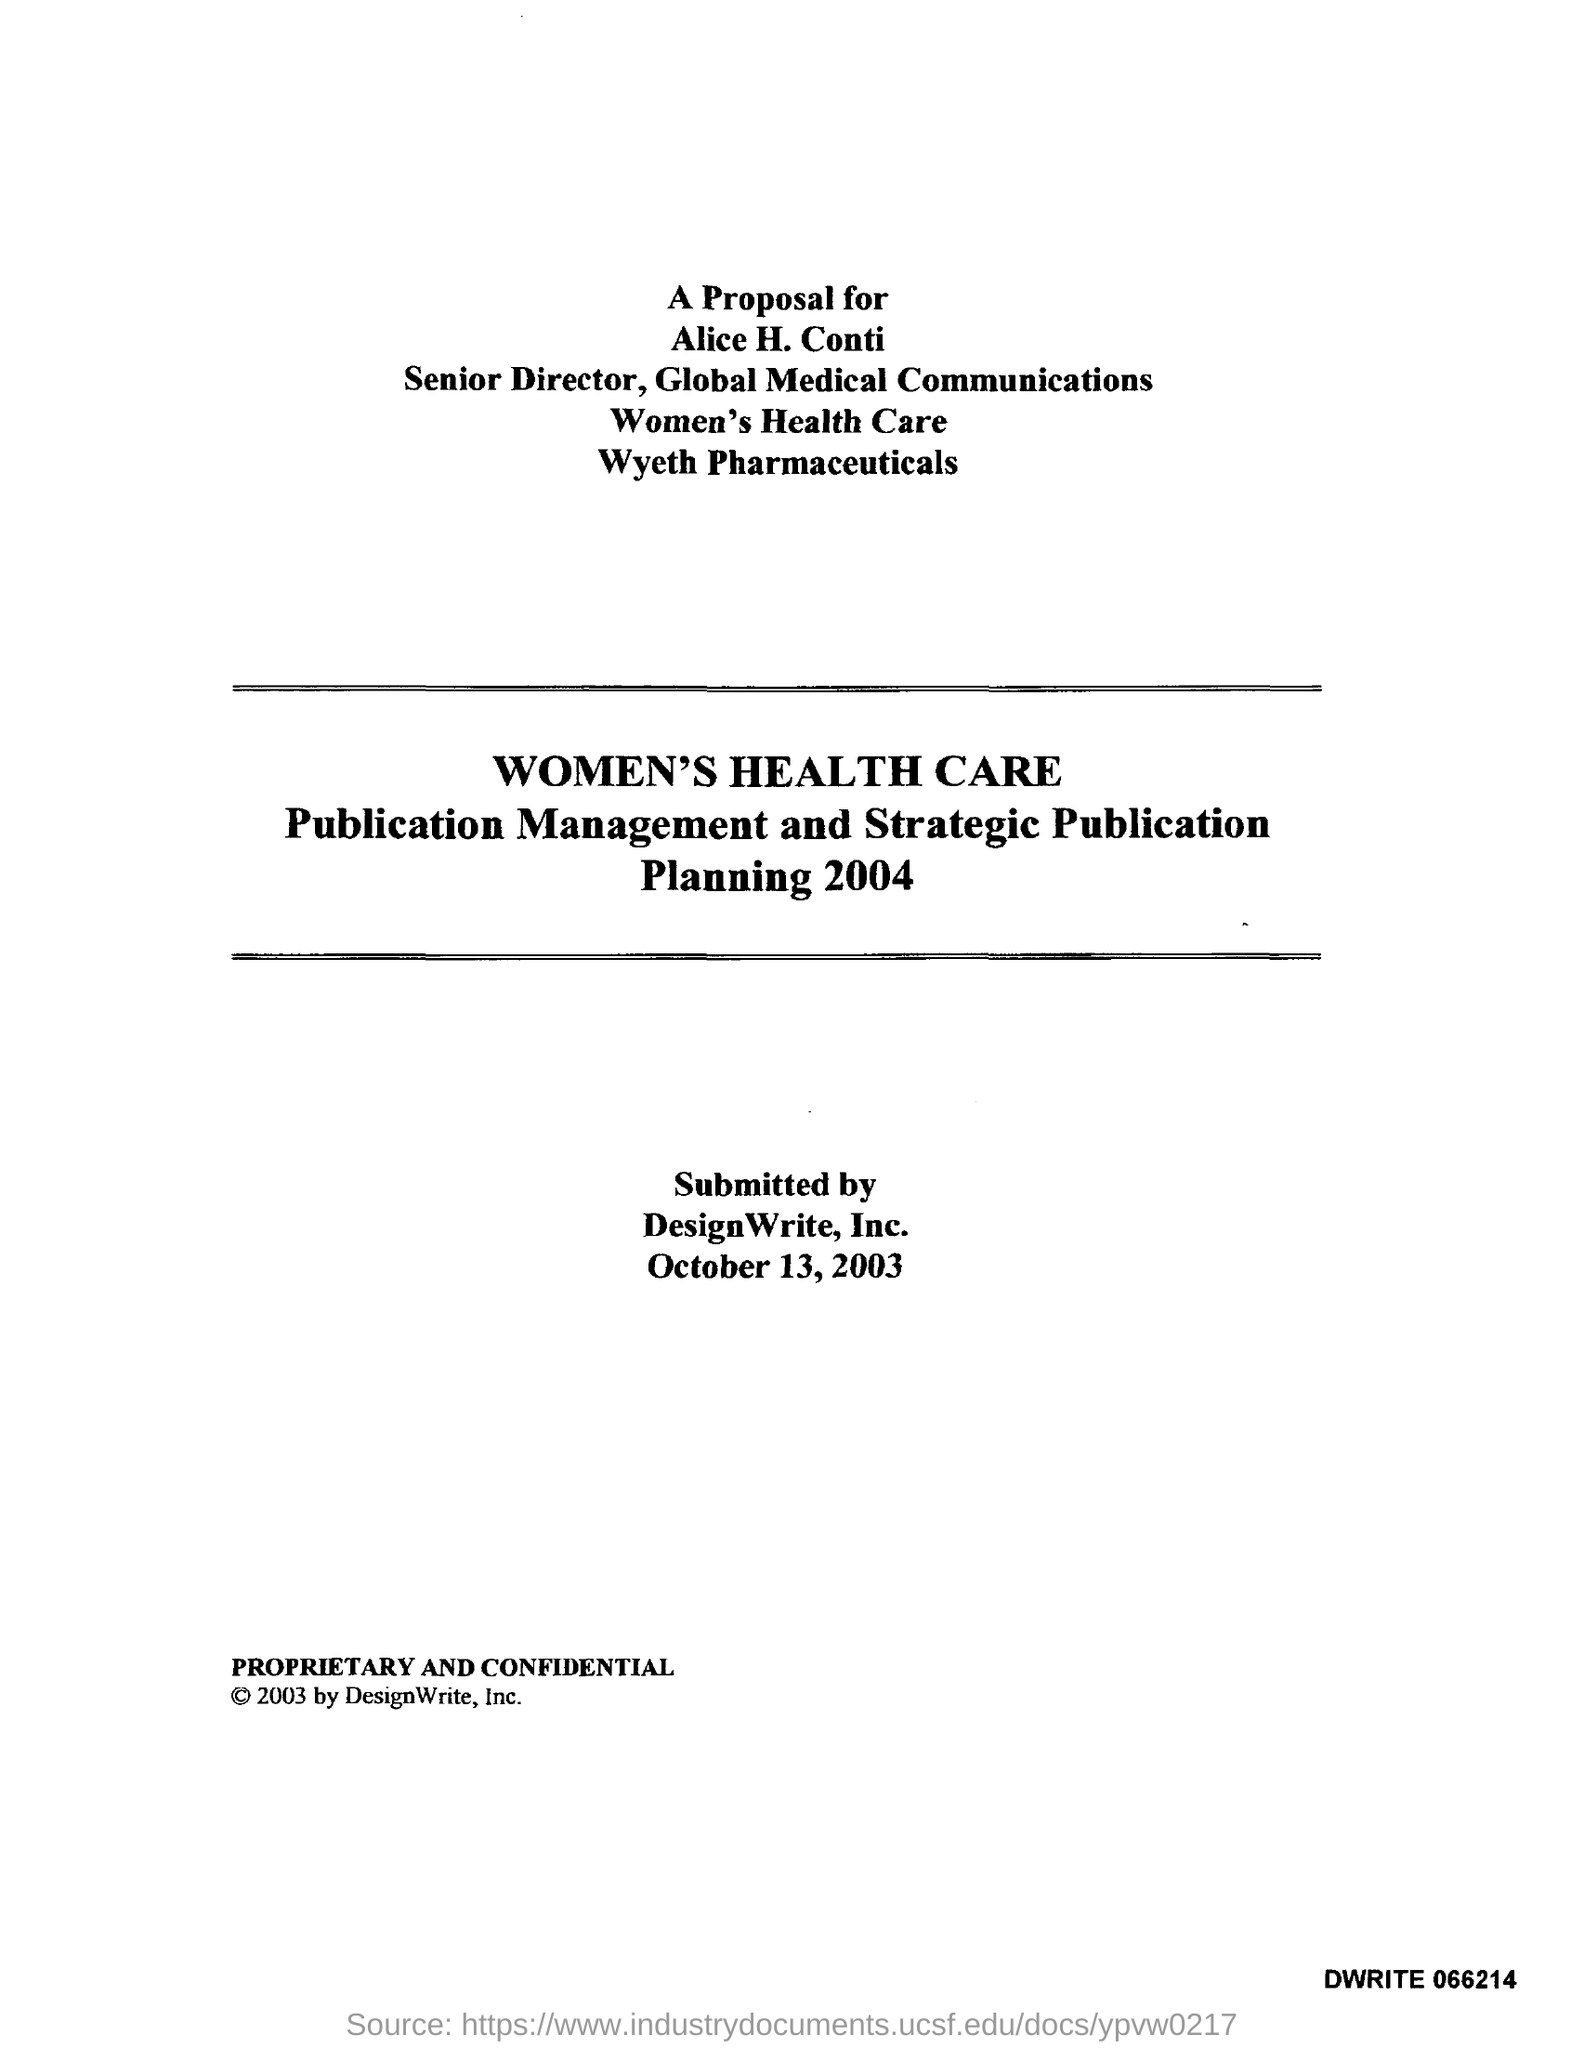What is the designation of alice h. conti ?
Your response must be concise. Senior director, global medical communications. 